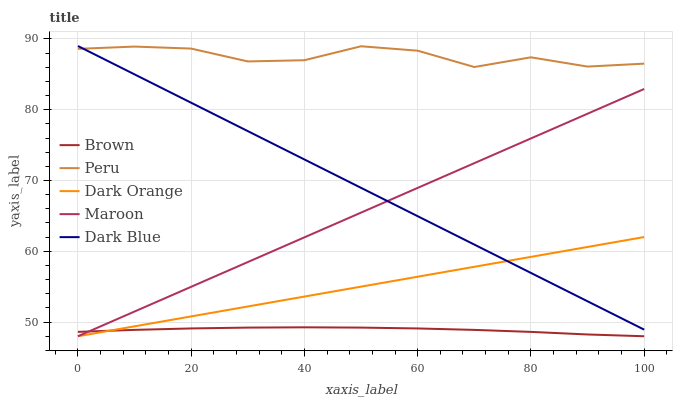Does Brown have the minimum area under the curve?
Answer yes or no. Yes. Does Peru have the maximum area under the curve?
Answer yes or no. Yes. Does Dark Blue have the minimum area under the curve?
Answer yes or no. No. Does Dark Blue have the maximum area under the curve?
Answer yes or no. No. Is Dark Orange the smoothest?
Answer yes or no. Yes. Is Peru the roughest?
Answer yes or no. Yes. Is Dark Blue the smoothest?
Answer yes or no. No. Is Dark Blue the roughest?
Answer yes or no. No. Does Brown have the lowest value?
Answer yes or no. Yes. Does Dark Blue have the lowest value?
Answer yes or no. No. Does Dark Blue have the highest value?
Answer yes or no. Yes. Does Maroon have the highest value?
Answer yes or no. No. Is Brown less than Peru?
Answer yes or no. Yes. Is Peru greater than Dark Orange?
Answer yes or no. Yes. Does Maroon intersect Dark Orange?
Answer yes or no. Yes. Is Maroon less than Dark Orange?
Answer yes or no. No. Is Maroon greater than Dark Orange?
Answer yes or no. No. Does Brown intersect Peru?
Answer yes or no. No. 